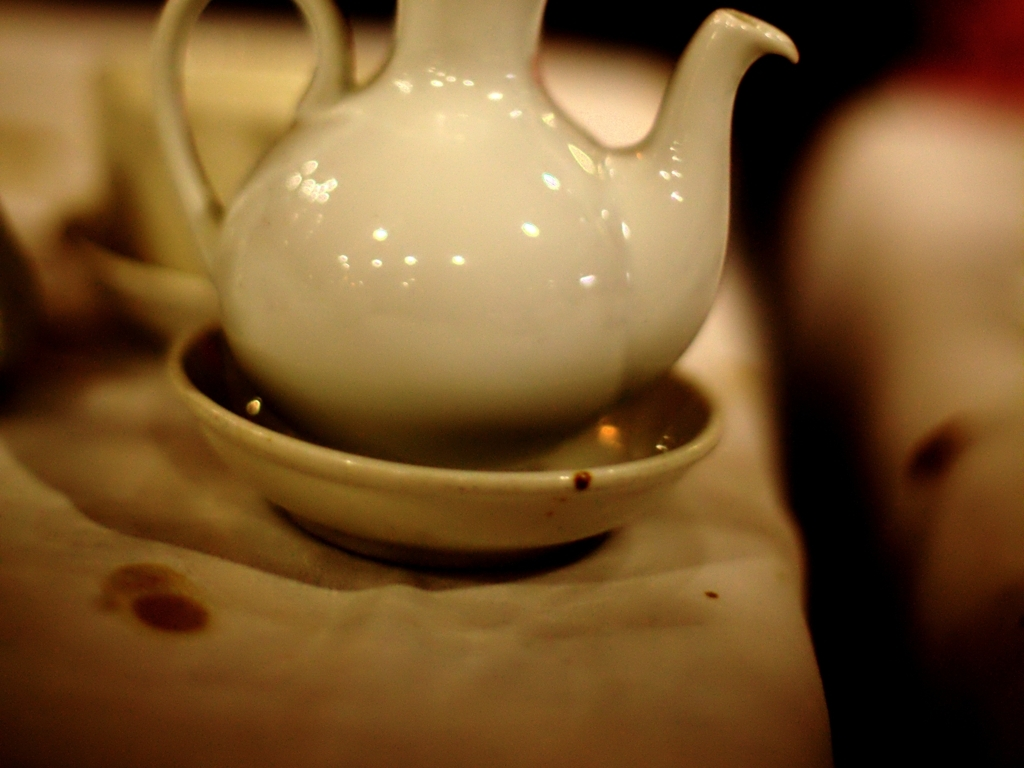Is the image clear? The image has a shallow depth of field with the focus on the teapot, which causes the background elements to appear blurred. This selective focus technique directs attention to the teapot, creating a visually aesthetic composition, despite some areas not being clear. 